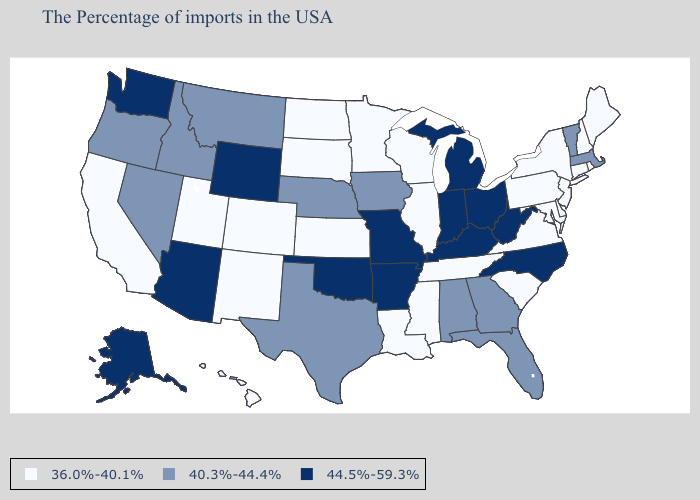Name the states that have a value in the range 40.3%-44.4%?
Quick response, please. Massachusetts, Vermont, Florida, Georgia, Alabama, Iowa, Nebraska, Texas, Montana, Idaho, Nevada, Oregon. What is the value of Kansas?
Be succinct. 36.0%-40.1%. Which states hav the highest value in the MidWest?
Give a very brief answer. Ohio, Michigan, Indiana, Missouri. Does the first symbol in the legend represent the smallest category?
Concise answer only. Yes. What is the lowest value in the USA?
Write a very short answer. 36.0%-40.1%. What is the value of Rhode Island?
Keep it brief. 36.0%-40.1%. Name the states that have a value in the range 40.3%-44.4%?
Give a very brief answer. Massachusetts, Vermont, Florida, Georgia, Alabama, Iowa, Nebraska, Texas, Montana, Idaho, Nevada, Oregon. Does Oregon have the lowest value in the West?
Keep it brief. No. Which states have the lowest value in the USA?
Quick response, please. Maine, Rhode Island, New Hampshire, Connecticut, New York, New Jersey, Delaware, Maryland, Pennsylvania, Virginia, South Carolina, Tennessee, Wisconsin, Illinois, Mississippi, Louisiana, Minnesota, Kansas, South Dakota, North Dakota, Colorado, New Mexico, Utah, California, Hawaii. Which states have the highest value in the USA?
Concise answer only. North Carolina, West Virginia, Ohio, Michigan, Kentucky, Indiana, Missouri, Arkansas, Oklahoma, Wyoming, Arizona, Washington, Alaska. Among the states that border Arkansas , does Louisiana have the lowest value?
Give a very brief answer. Yes. Name the states that have a value in the range 36.0%-40.1%?
Be succinct. Maine, Rhode Island, New Hampshire, Connecticut, New York, New Jersey, Delaware, Maryland, Pennsylvania, Virginia, South Carolina, Tennessee, Wisconsin, Illinois, Mississippi, Louisiana, Minnesota, Kansas, South Dakota, North Dakota, Colorado, New Mexico, Utah, California, Hawaii. Does Michigan have a lower value than Colorado?
Give a very brief answer. No. Among the states that border North Dakota , does Montana have the lowest value?
Quick response, please. No. Name the states that have a value in the range 40.3%-44.4%?
Short answer required. Massachusetts, Vermont, Florida, Georgia, Alabama, Iowa, Nebraska, Texas, Montana, Idaho, Nevada, Oregon. 